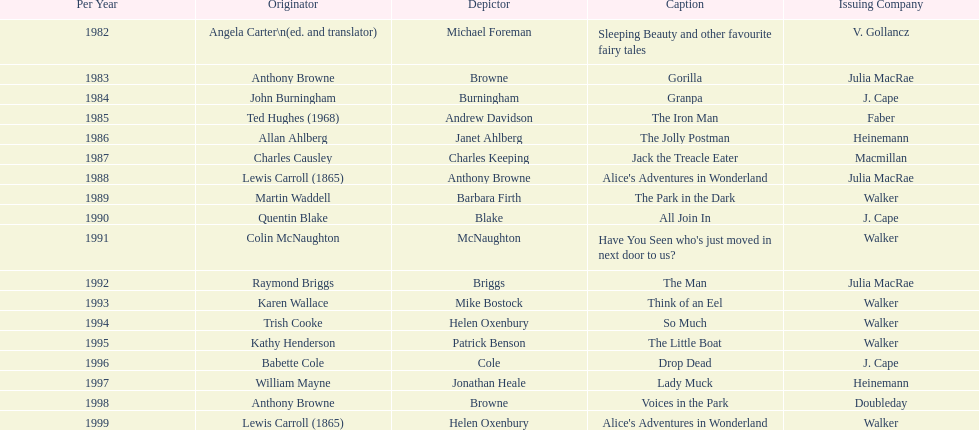Which other author, besides lewis carroll, has won the kurt maschler award twice? Anthony Browne. 